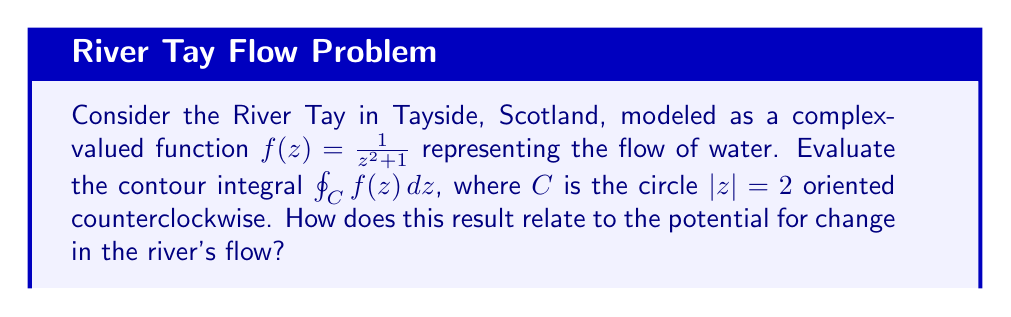Solve this math problem. Let's approach this step-by-step:

1) First, we need to determine if there are any singularities inside the contour. The function $f(z) = \frac{1}{z^2 + 1}$ has poles at $z = \pm i$.

2) Since $|z| = 2$, the contour encloses both these poles.

3) We can use the Residue Theorem, which states:

   $$\oint_C f(z) dz = 2\pi i \sum \text{Res}(f, a_k)$$

   where $a_k$ are the poles of $f(z)$ inside $C$.

4) To find the residues, we need to calculate:

   $$\text{Res}(f, i) = \lim_{z \to i} (z-i)f(z) = \lim_{z \to i} \frac{z-i}{z^2+1} = \frac{1}{2i}$$

   $$\text{Res}(f, -i) = \lim_{z \to -i} (z+i)f(z) = \lim_{z \to -i} \frac{z+i}{z^2+1} = -\frac{1}{2i}$$

5) Summing these residues:

   $$\sum \text{Res}(f, a_k) = \frac{1}{2i} - \frac{1}{2i} = 0$$

6) Therefore, applying the Residue Theorem:

   $$\oint_C f(z) dz = 2\pi i \cdot 0 = 0$$

This result suggests that there is no net flow across the contour, which could be interpreted as a balance in the river's current system. For a resident unhappy with the current state but hopeful for change, this balance might represent an opportunity for managed interventions to improve the river's condition without disrupting its overall equilibrium.
Answer: $$\oint_C f(z) dz = 0$$ 